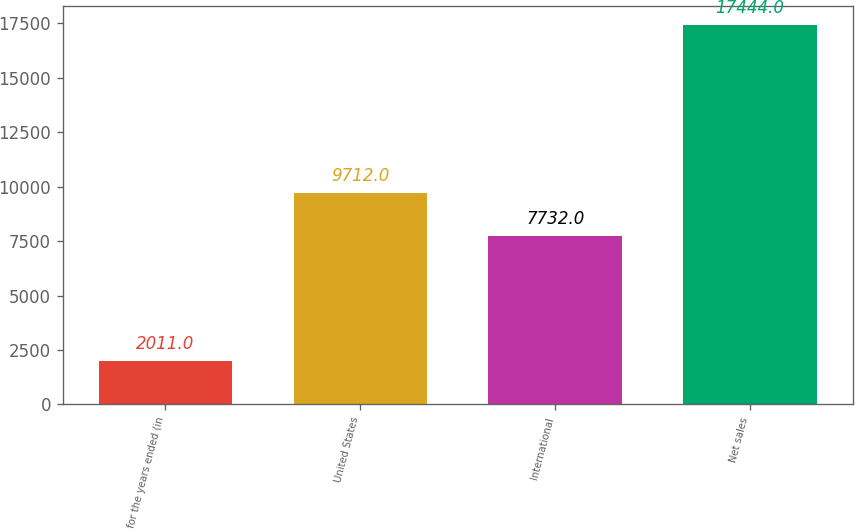<chart> <loc_0><loc_0><loc_500><loc_500><bar_chart><fcel>for the years ended (in<fcel>United States<fcel>International<fcel>Net sales<nl><fcel>2011<fcel>9712<fcel>7732<fcel>17444<nl></chart> 